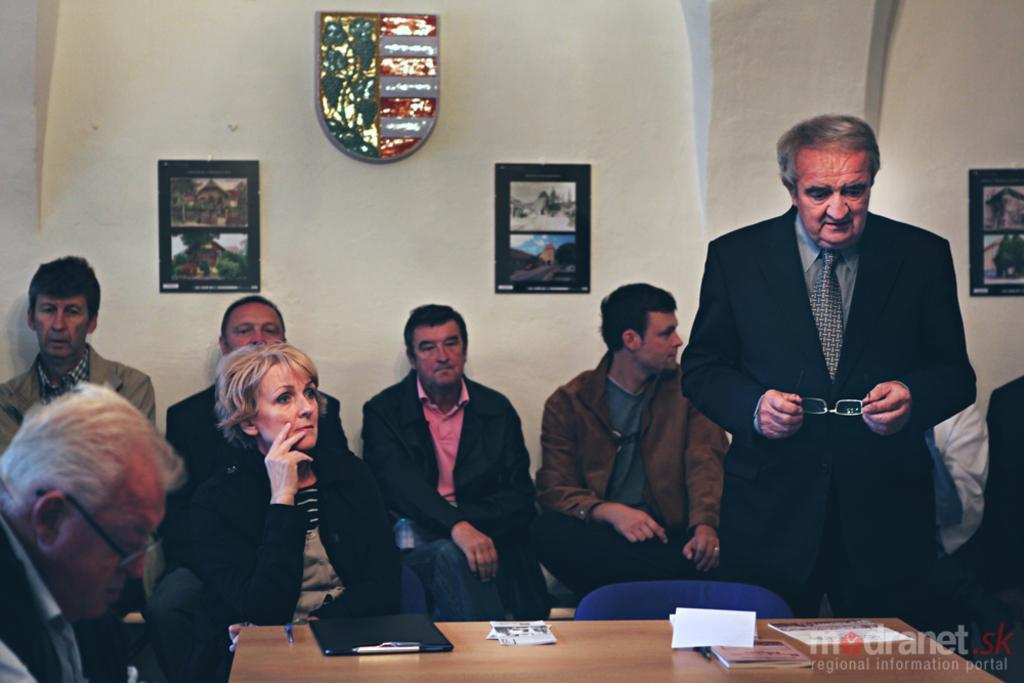Describe this image in one or two sentences. In the right side an old man is standing, he is holding spectacles in his hands. He wore a black color coat, in the left side a woman is sitting, she wore a black color coat, behind her there are few men are also sitting and this is a wall. 